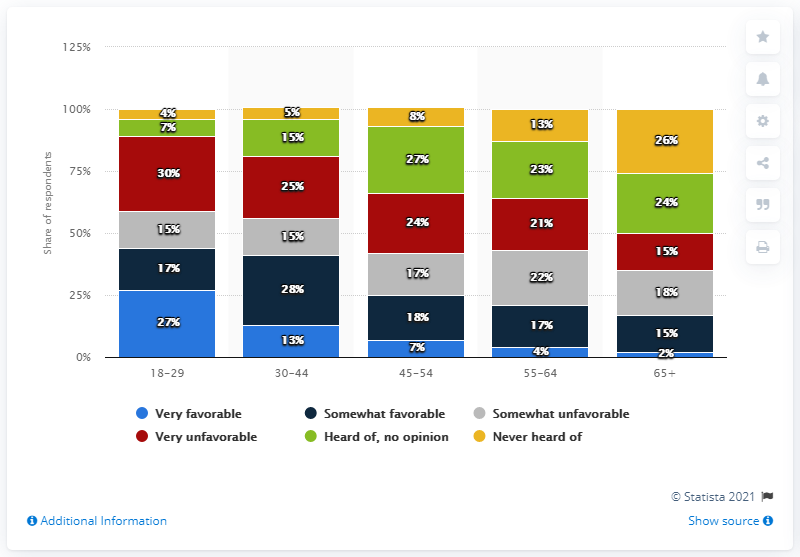Specify some key components in this picture. The average of very favorable is 10.6. Yellow is the color that Never heard of represents. 